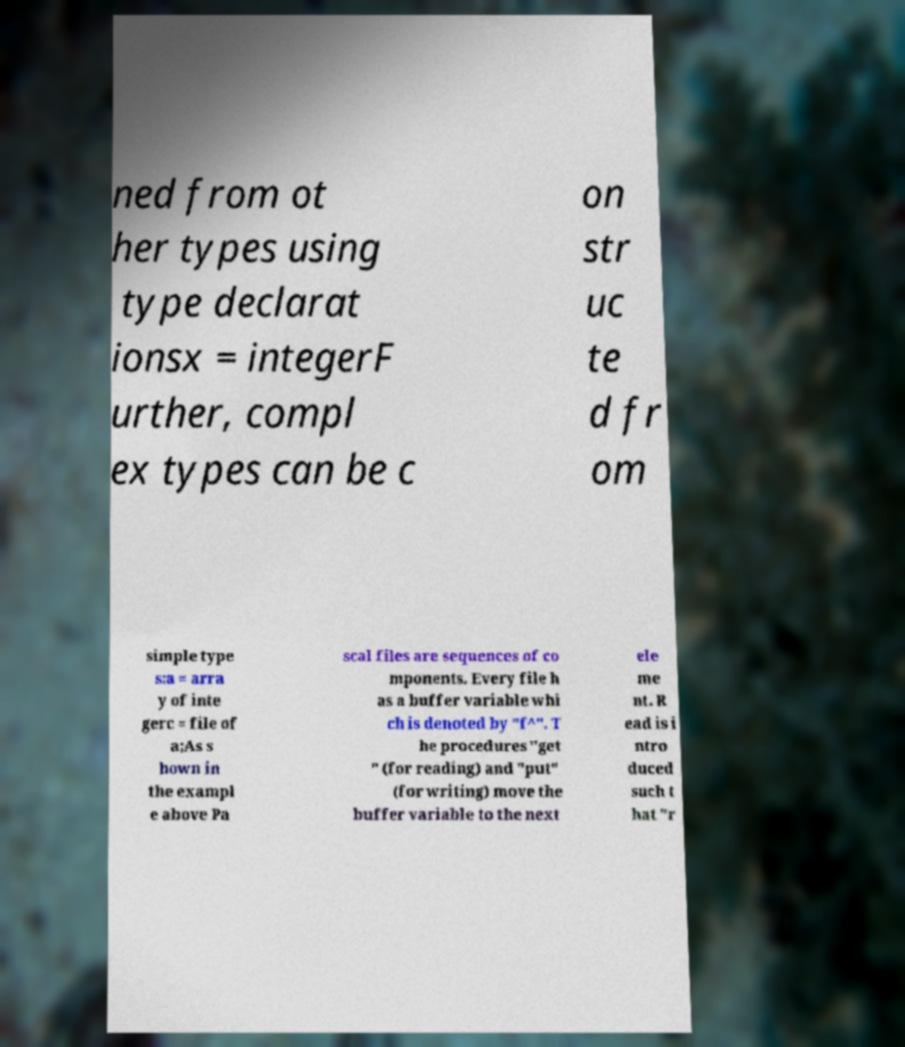Can you accurately transcribe the text from the provided image for me? ned from ot her types using type declarat ionsx = integerF urther, compl ex types can be c on str uc te d fr om simple type s:a = arra y of inte gerc = file of a;As s hown in the exampl e above Pa scal files are sequences of co mponents. Every file h as a buffer variable whi ch is denoted by "f^". T he procedures "get " (for reading) and "put" (for writing) move the buffer variable to the next ele me nt. R ead is i ntro duced such t hat "r 